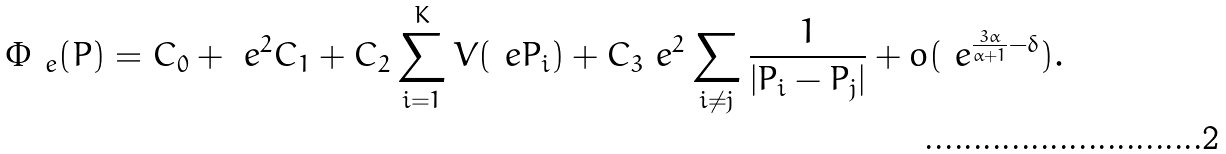Convert formula to latex. <formula><loc_0><loc_0><loc_500><loc_500>\Phi _ { \ e } ( { P } ) = C _ { 0 } + \ e ^ { 2 } C _ { 1 } + C _ { 2 } \sum _ { i = 1 } ^ { K } V ( \ e P _ { i } ) + C _ { 3 } \ e ^ { 2 } \sum _ { i \neq j } \frac { 1 } { | P _ { i } - P _ { j } | } + o ( \ e ^ { \frac { 3 \alpha } { \alpha + 1 } - \delta } ) .</formula> 